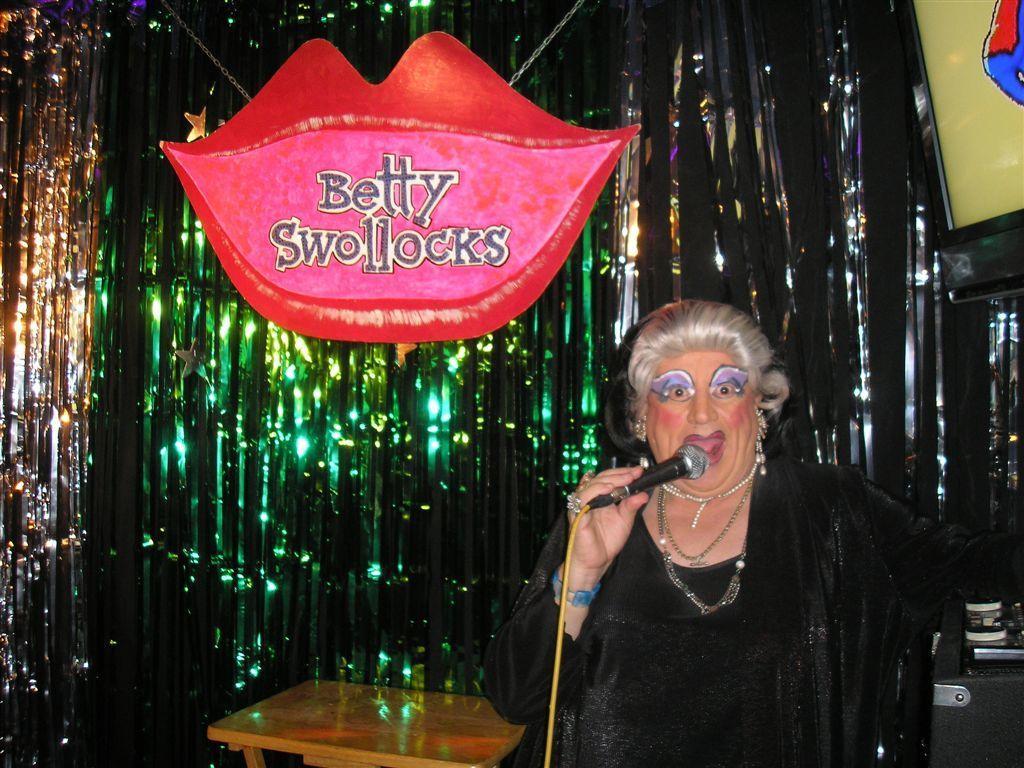Describe this image in one or two sentences. There is a woman in the image in which she is holding a microphone on her hand and she is also wearing a watch which is in blue color and opened her mouth for singing. On left side we can see a table. On right side we can another table on which we can see some books and remote. In background we see lips which are in red color and labelled as betty swollocks. 